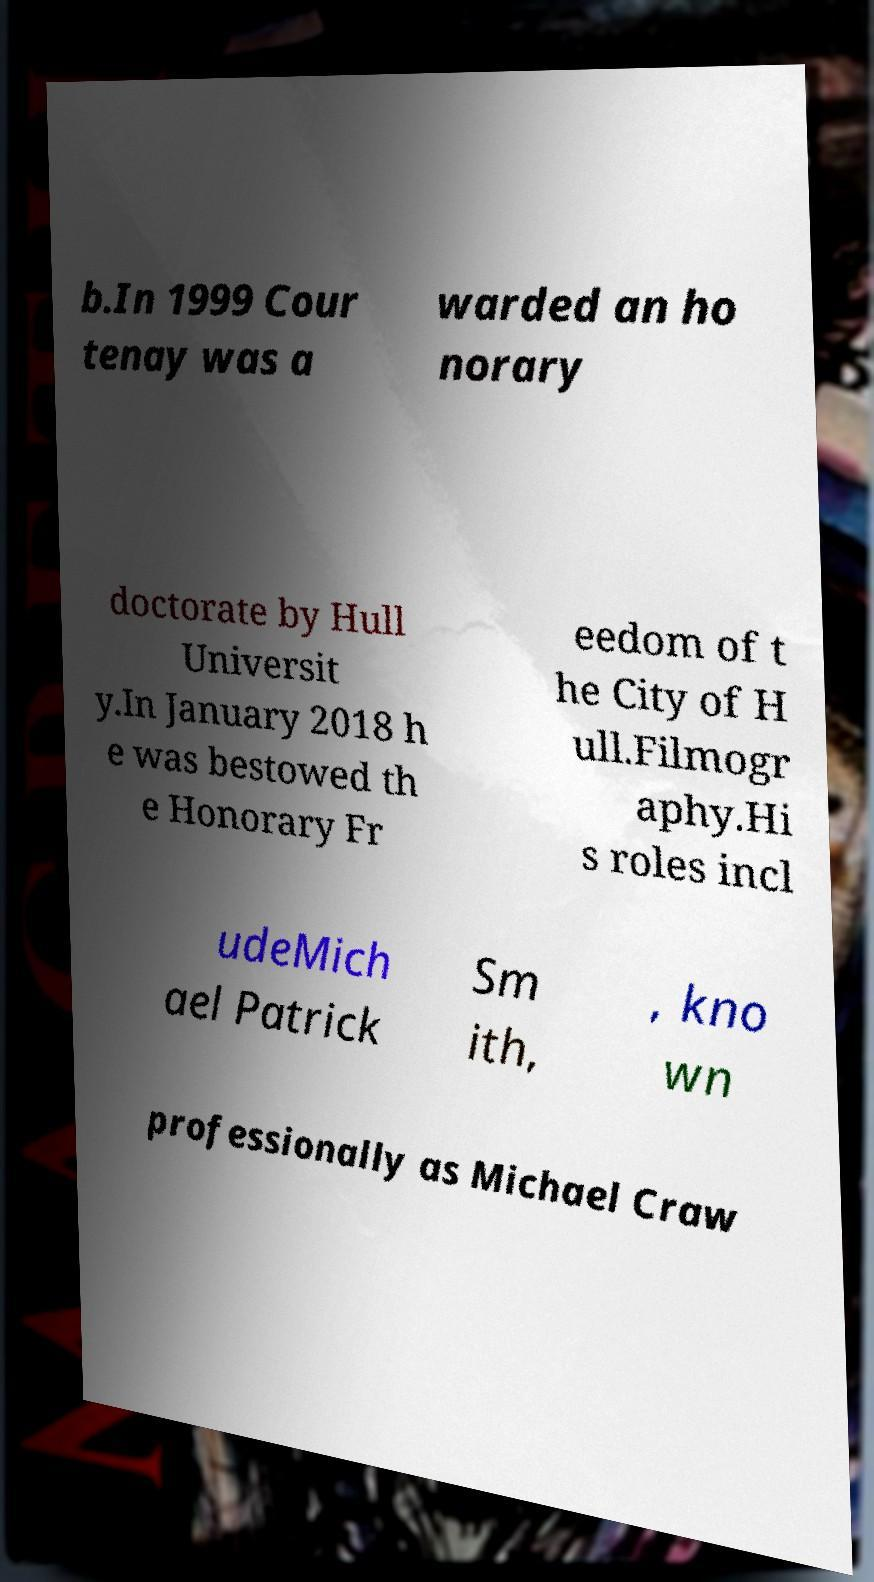Can you read and provide the text displayed in the image?This photo seems to have some interesting text. Can you extract and type it out for me? b.In 1999 Cour tenay was a warded an ho norary doctorate by Hull Universit y.In January 2018 h e was bestowed th e Honorary Fr eedom of t he City of H ull.Filmogr aphy.Hi s roles incl udeMich ael Patrick Sm ith, , kno wn professionally as Michael Craw 